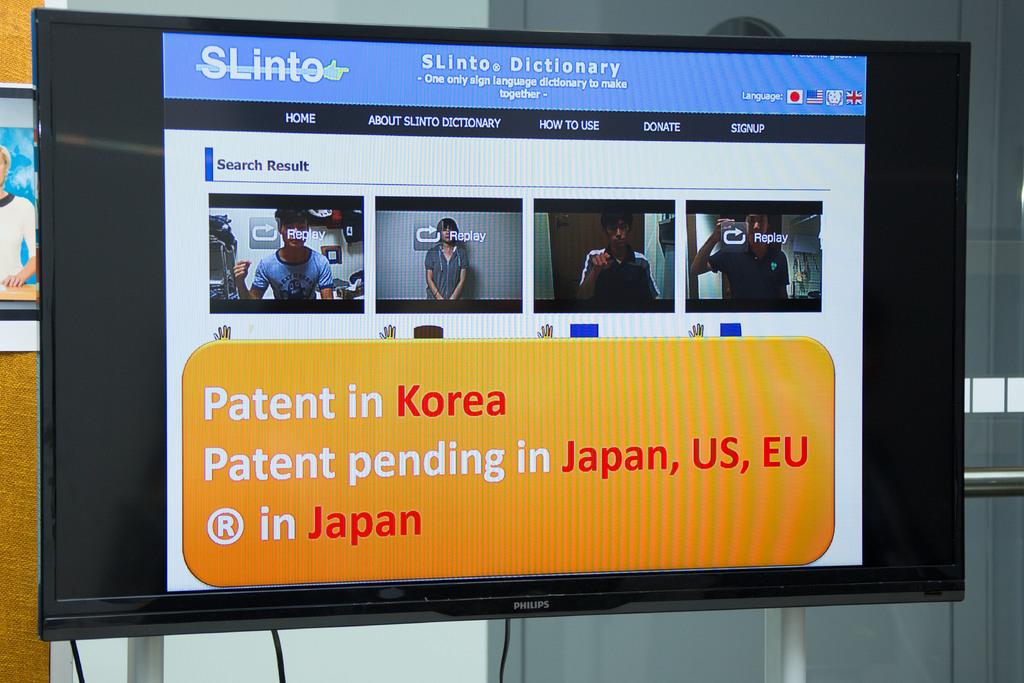Provide a one-sentence caption for the provided image. Monitor showing the patent pending with screens of people. 